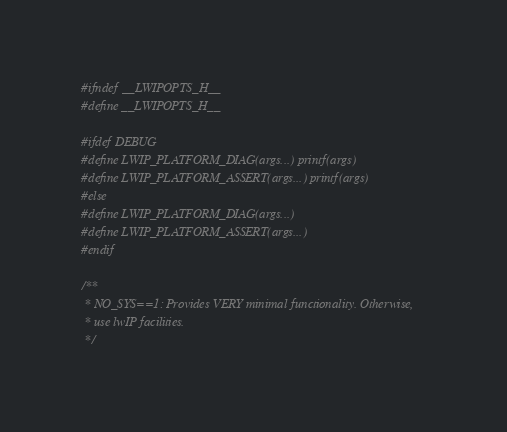Convert code to text. <code><loc_0><loc_0><loc_500><loc_500><_C_>#ifndef __LWIPOPTS_H__
#define __LWIPOPTS_H__

#ifdef DEBUG
#define LWIP_PLATFORM_DIAG(args...) printf(args)
#define LWIP_PLATFORM_ASSERT(args...) printf(args)
#else
#define LWIP_PLATFORM_DIAG(args...)
#define LWIP_PLATFORM_ASSERT(args...)
#endif

/**
 * NO_SYS==1: Provides VERY minimal functionality. Otherwise,
 * use lwIP facilities.
 */</code> 